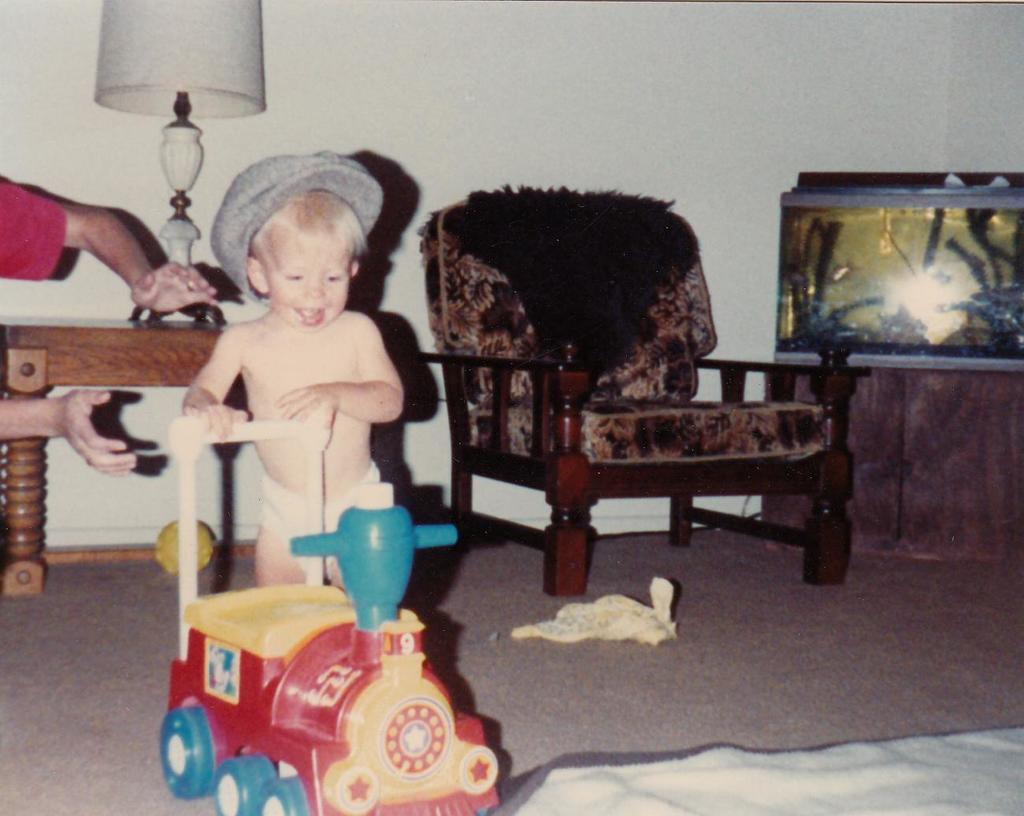What is the child doing in the image? The child is playing with a toy in the image. Whose hands are visible in the image? Two hands are visible in the image. What can be seen in the background of the image? There is a table, a lamp, and an aquarium in the background of the image. What type of twig is the child using to play with the toy in the image? There is no twig present in the image; the child is playing with a toy. What disease is the child suffering from in the image? There is no indication of any disease in the image; the child is simply playing with a toy. 